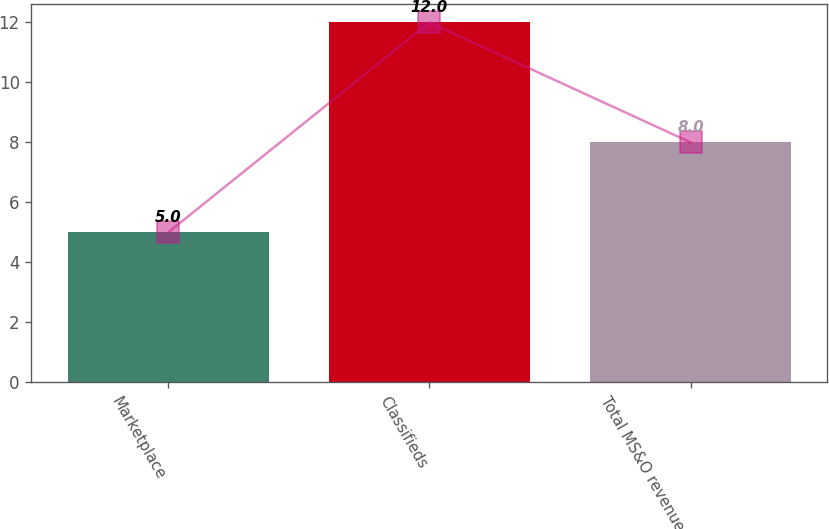Convert chart. <chart><loc_0><loc_0><loc_500><loc_500><bar_chart><fcel>Marketplace<fcel>Classifieds<fcel>Total MS&O revenues<nl><fcel>5<fcel>12<fcel>8<nl></chart> 